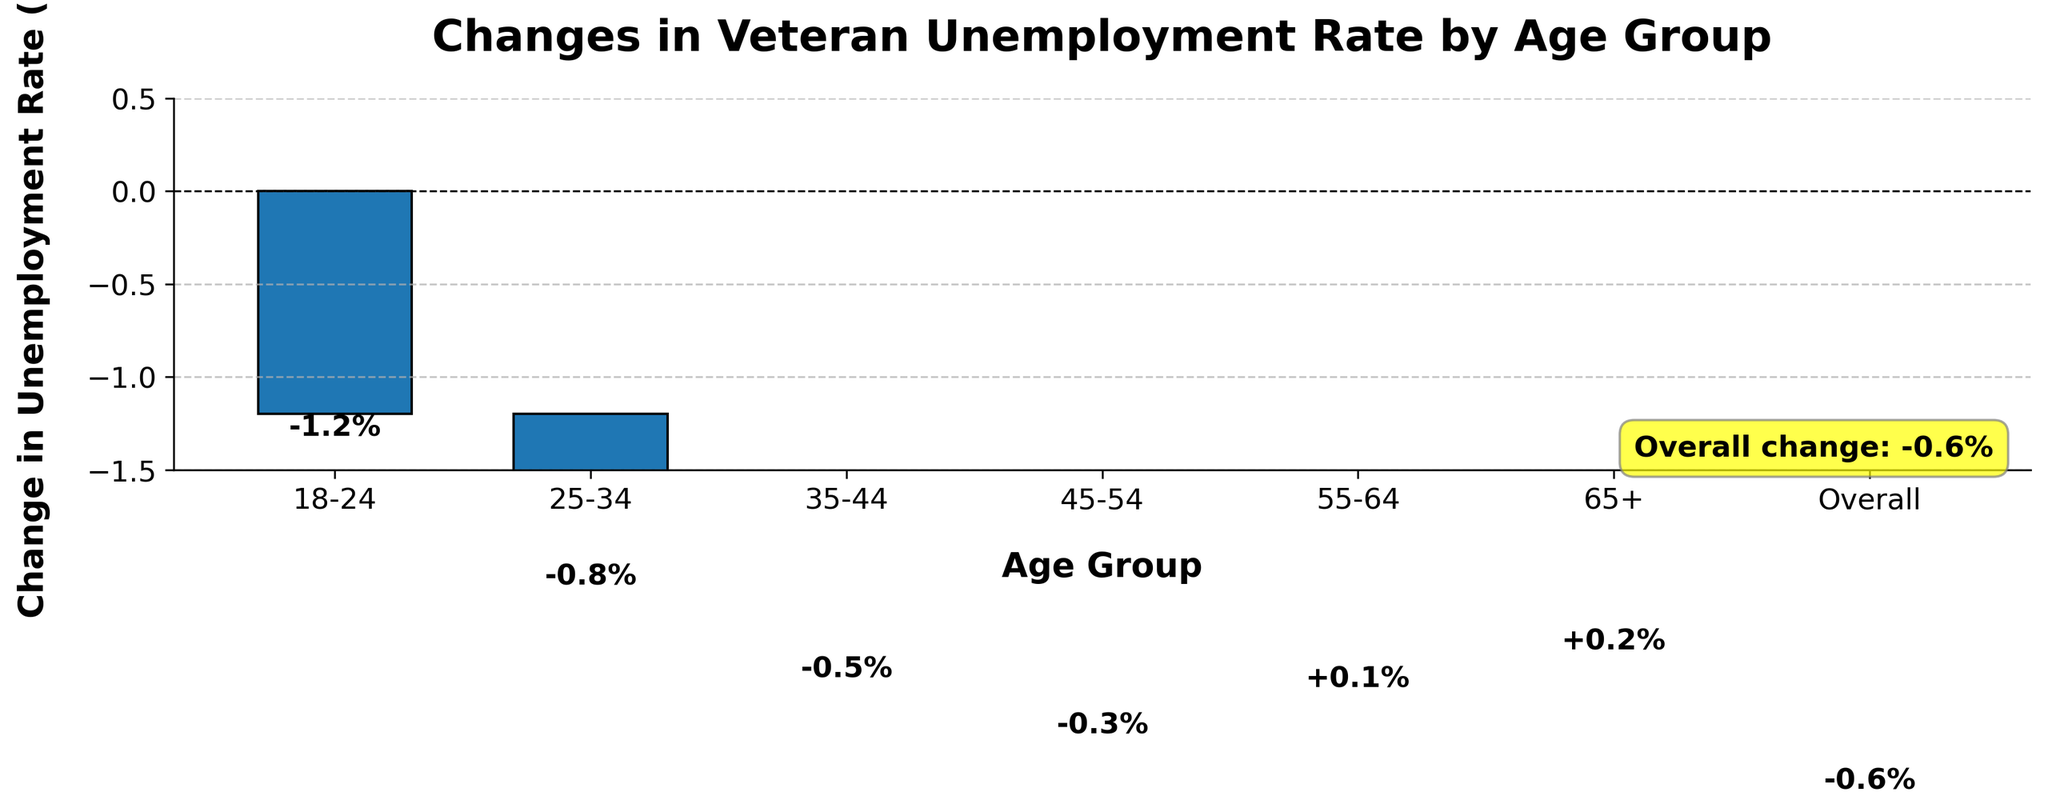What is the overall change in the unemployment rate for veterans across all age groups? The overall change is given as -0.6%, indicated by both the actual data and the annotation on the chart.
Answer: -0.6% How has the unemployment rate changed for the age group 18-24? The change is shown on the bar representing the age group 18-24, which is labeled with -1.2%.
Answer: -1.2% Which age group experienced the greatest increase in the unemployment rate? The age group with the highest positive change is 65+, as shown by the bar with a label of +0.2%.
Answer: 65+ Compare the unemployment rate changes between the 18-24 and 25-34 age groups. Which group saw a larger decrease? The 18-24 age group saw a decrease of -1.2%, whereas the 25-34 age group saw a decrease of -0.8%. Comparing these, -1.2% is a larger decrease.
Answer: 18-24 Which age group experienced a slight increase in the unemployment rate? The age groups 55-64 and 65+ show slight increases, with changes of +0.1% and +0.2%, respectively.
Answer: 55-64 and 65+ What is the difference in the unemployment rate change between the 35-44 and the 45-54 age groups? The unemployment rate changed by -0.5% for the 35-44 age group and -0.3% for the 45-54 age group. The difference is -0.5% - (-0.3%) = -0.2%.
Answer: -0.2% Which age group saw the smallest change in the unemployment rate? The age group 55-64 saw the smallest change, with a change of +0.1%.
Answer: 55-64 How many age groups experienced a decrease in the unemployment rate? Visual inspection shows negative changes for the age groups 18-24, 25-34, 35-44, and 45-54, totaling four groups.
Answer: 4 What is the cumulative change for all the age groups up to 45-54? Cumulative change is calculated as -1.2% + (-0.8%) + (-0.5%) + (-0.3%) = -2.8%.
Answer: -2.8% How does the overall change compare to the change in the 25-34 age group? The overall change is -0.6%, and the change for the 25-34 age group is -0.8%. The overall change is a smaller decrease compared to -0.8%.
Answer: The overall change is smaller than 25-34 